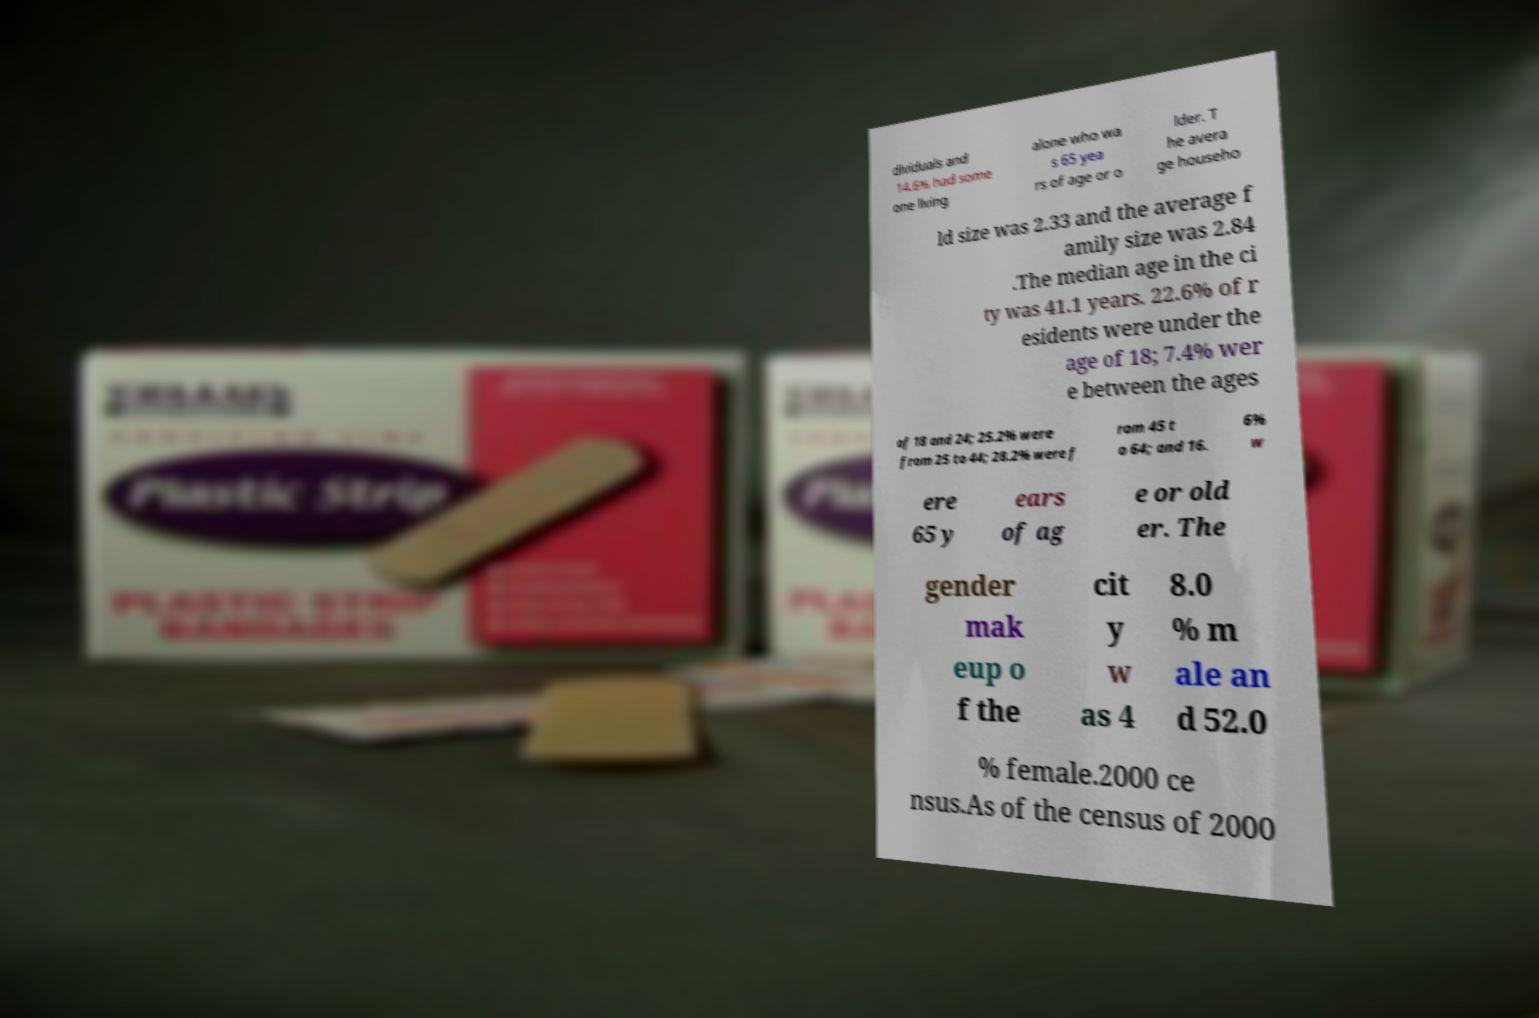There's text embedded in this image that I need extracted. Can you transcribe it verbatim? dividuals and 14.6% had some one living alone who wa s 65 yea rs of age or o lder. T he avera ge househo ld size was 2.33 and the average f amily size was 2.84 .The median age in the ci ty was 41.1 years. 22.6% of r esidents were under the age of 18; 7.4% wer e between the ages of 18 and 24; 25.2% were from 25 to 44; 28.2% were f rom 45 t o 64; and 16. 6% w ere 65 y ears of ag e or old er. The gender mak eup o f the cit y w as 4 8.0 % m ale an d 52.0 % female.2000 ce nsus.As of the census of 2000 